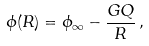<formula> <loc_0><loc_0><loc_500><loc_500>\phi ( R ) = \phi _ { \infty } - \frac { G Q } { R } \, ,</formula> 